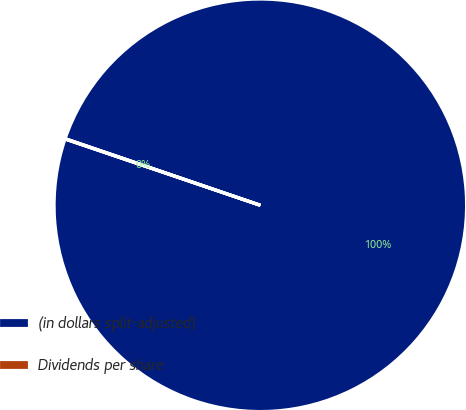<chart> <loc_0><loc_0><loc_500><loc_500><pie_chart><fcel>(in dollars split-adjusted)<fcel>Dividends per share<nl><fcel>99.97%<fcel>0.03%<nl></chart> 